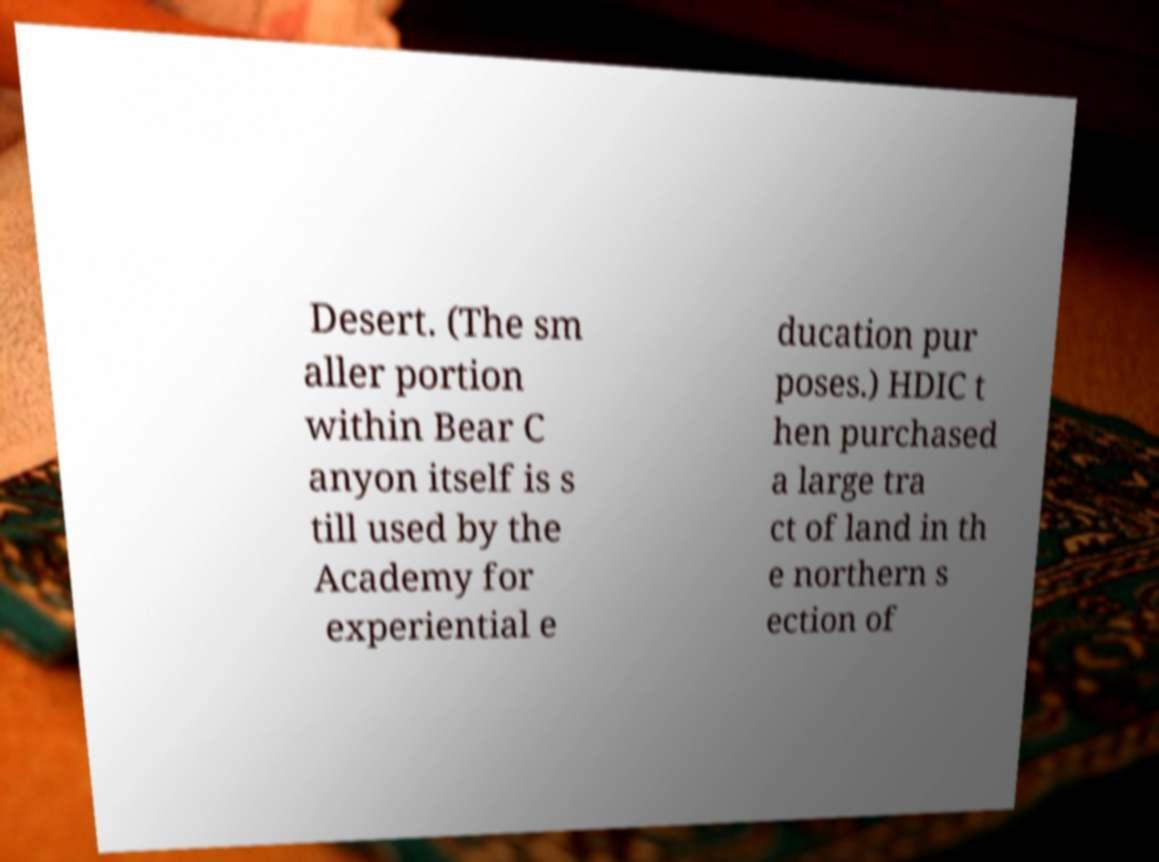Can you accurately transcribe the text from the provided image for me? Desert. (The sm aller portion within Bear C anyon itself is s till used by the Academy for experiential e ducation pur poses.) HDIC t hen purchased a large tra ct of land in th e northern s ection of 